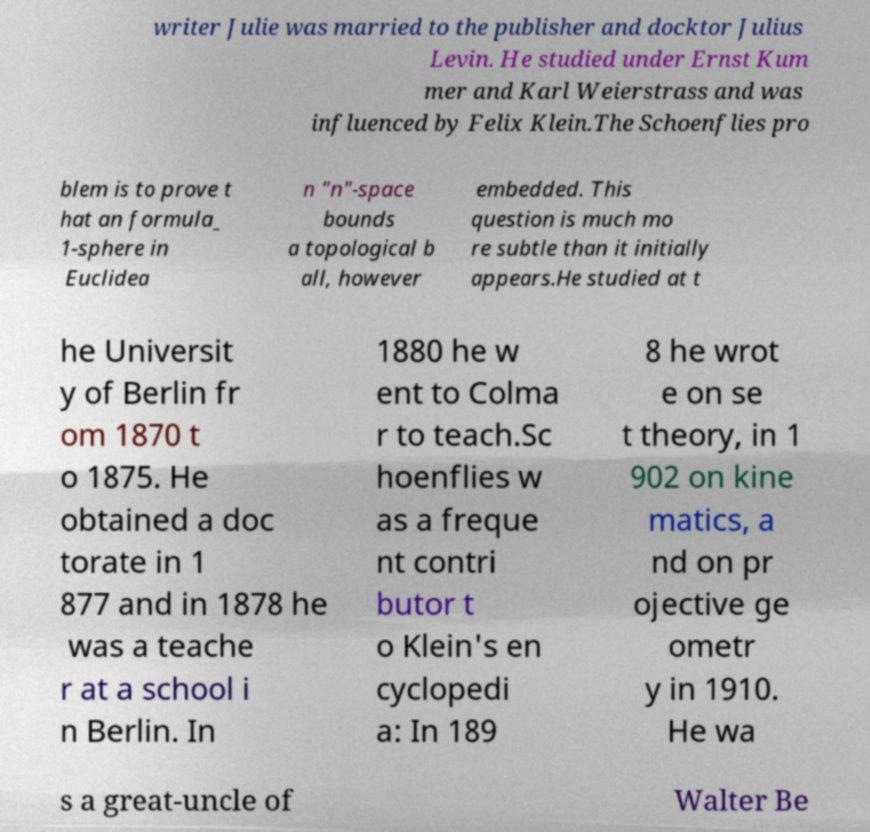Could you extract and type out the text from this image? writer Julie was married to the publisher and docktor Julius Levin. He studied under Ernst Kum mer and Karl Weierstrass and was influenced by Felix Klein.The Schoenflies pro blem is to prove t hat an formula_ 1-sphere in Euclidea n "n"-space bounds a topological b all, however embedded. This question is much mo re subtle than it initially appears.He studied at t he Universit y of Berlin fr om 1870 t o 1875. He obtained a doc torate in 1 877 and in 1878 he was a teache r at a school i n Berlin. In 1880 he w ent to Colma r to teach.Sc hoenflies w as a freque nt contri butor t o Klein's en cyclopedi a: In 189 8 he wrot e on se t theory, in 1 902 on kine matics, a nd on pr ojective ge ometr y in 1910. He wa s a great-uncle of Walter Be 